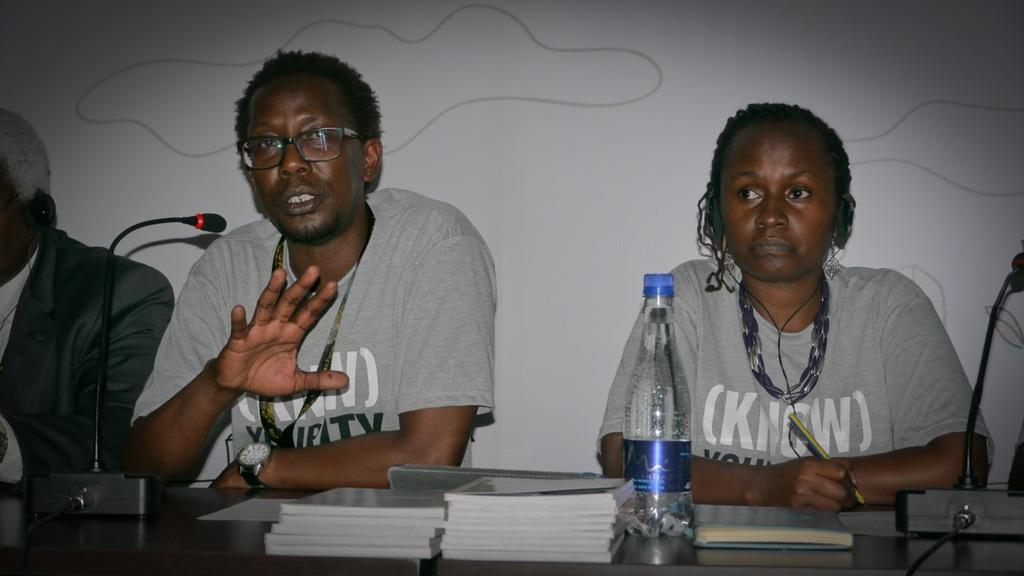What is the man in the image doing? The man is speaking into a microphone. What is the man wearing in the image? The man is wearing a T-shirt. What object can be seen on a table in the image? There is a water bottle on a table in the image. Who else is present in the image? There is a woman sitting in the image. How many legs does the bedroom have in the image? There is no bedroom present in the image, so it is not possible to determine how many legs it might have. 